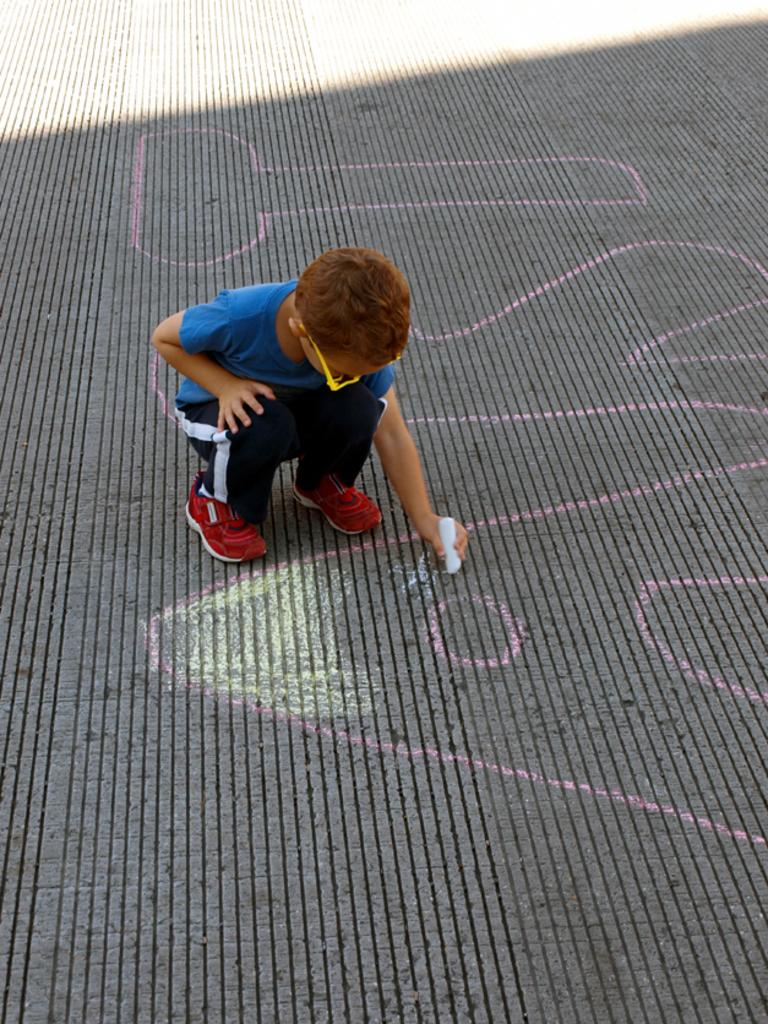Who is present in the image? There is a boy in the image. What is the boy doing in the image? The boy is sitting in the image. What is the boy holding in his hand? The boy is holding a chalk in his hand. What can be seen on the ground in the image? Something is written on the ground in the image. What type of government is depicted in the image? There is no depiction of a government in the image. 